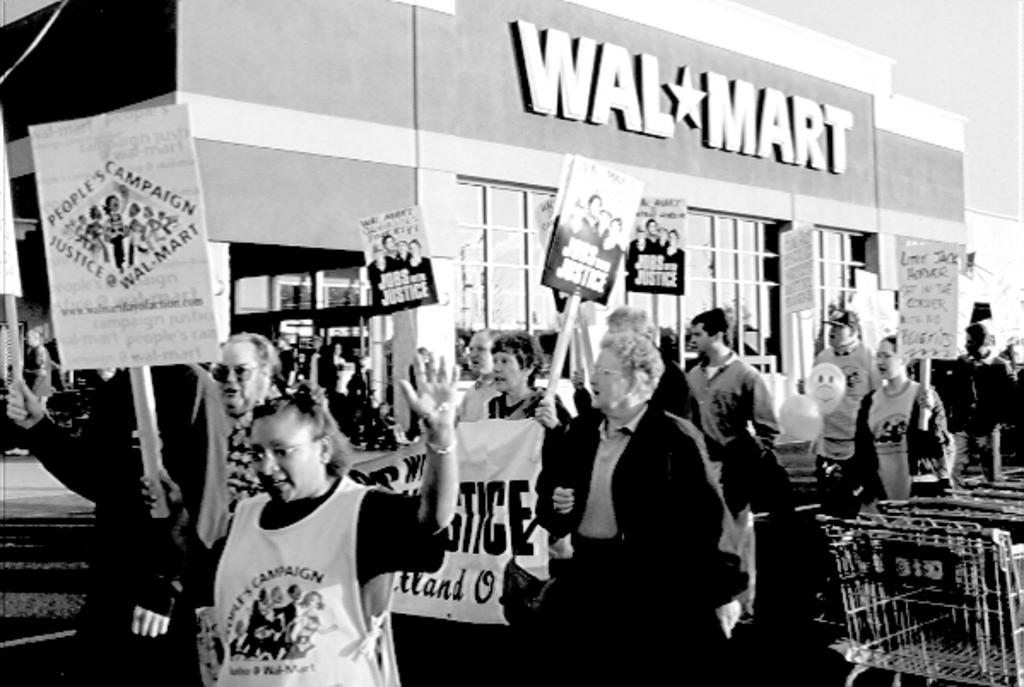What is the color scheme of the image? The image is black and white. What are the people in the image doing? The people in the image are protesting. What are the protesters holding in their hands? A: The protesters are holding posters in their hands. What can be seen in the background of the image? There is a mall in the background of the image. What type of pollution is being addressed by the protesters in the image? There is no indication of pollution in the image; the protesters are holding posters, but their message is not visible or described. 